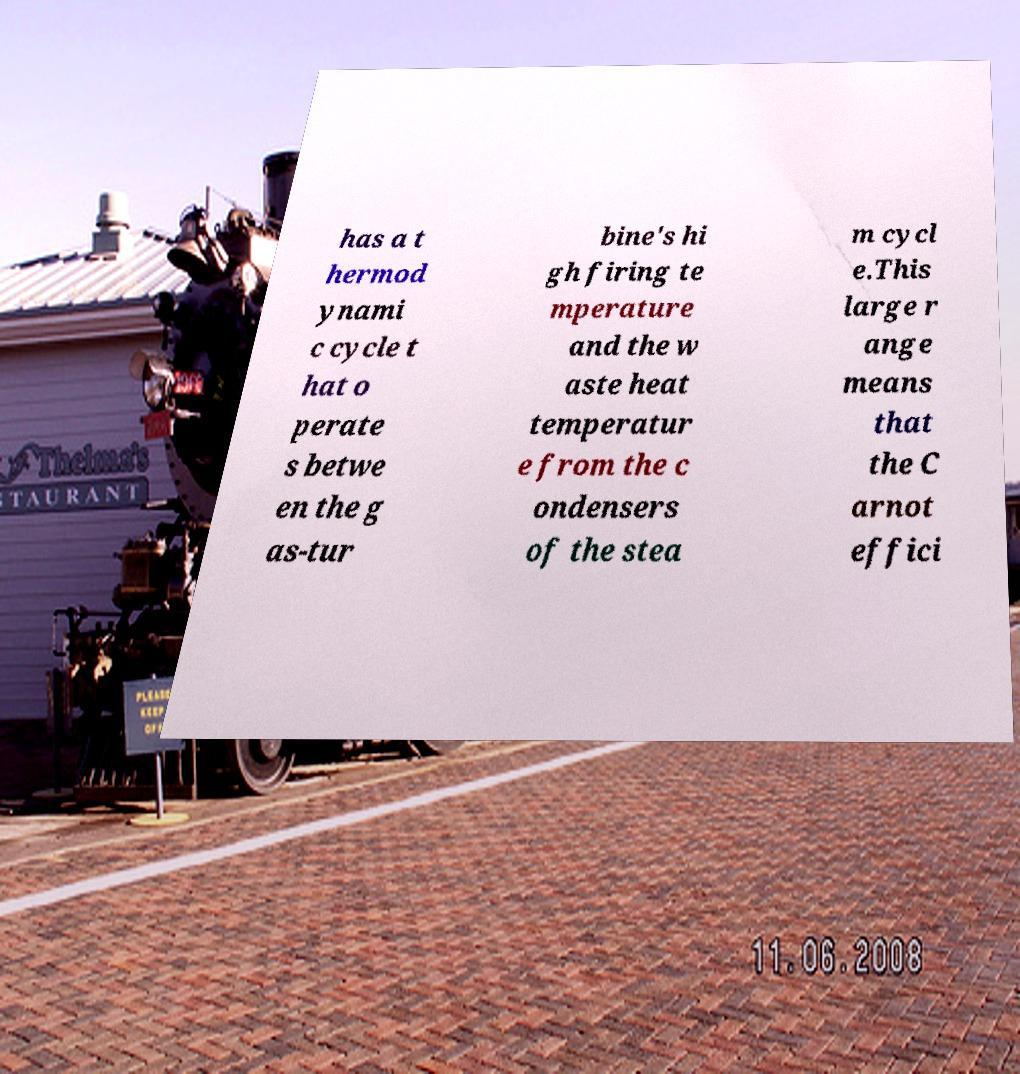Can you accurately transcribe the text from the provided image for me? has a t hermod ynami c cycle t hat o perate s betwe en the g as-tur bine's hi gh firing te mperature and the w aste heat temperatur e from the c ondensers of the stea m cycl e.This large r ange means that the C arnot effici 